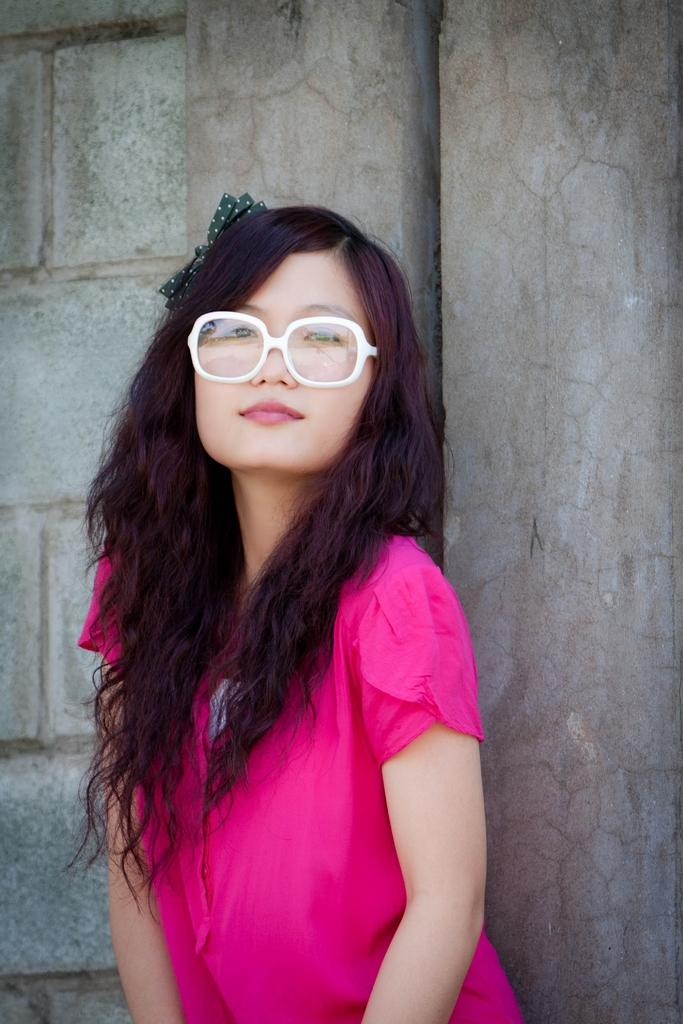Who is the main subject in the image? There is a woman in the image. What is the woman wearing? The woman is wearing a pink dress. Where is the woman standing? The woman is standing on a path. What can be seen behind the woman? There is a wall behind the woman. What type of caption is written on the woman's dress in the image? There is no caption written on the woman's dress in the image. Can you tell me what store the woman bought her dress from? The provided facts do not give any information about where the woman bought her dress. 